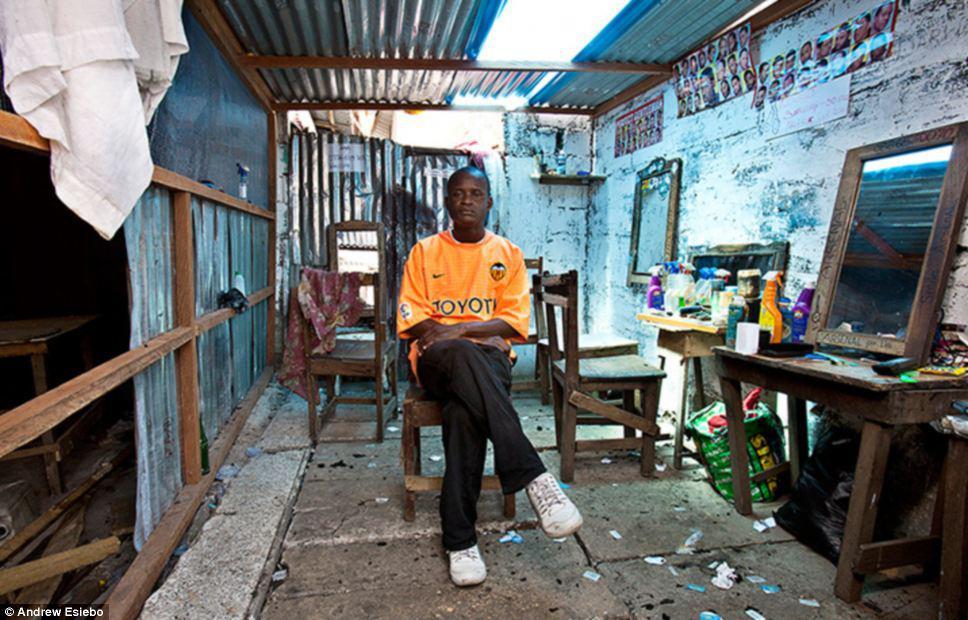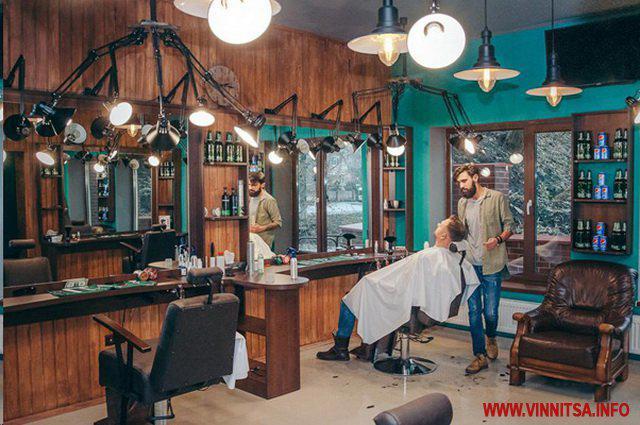The first image is the image on the left, the second image is the image on the right. Analyze the images presented: Is the assertion "There are people in both images." valid? Answer yes or no. Yes. 